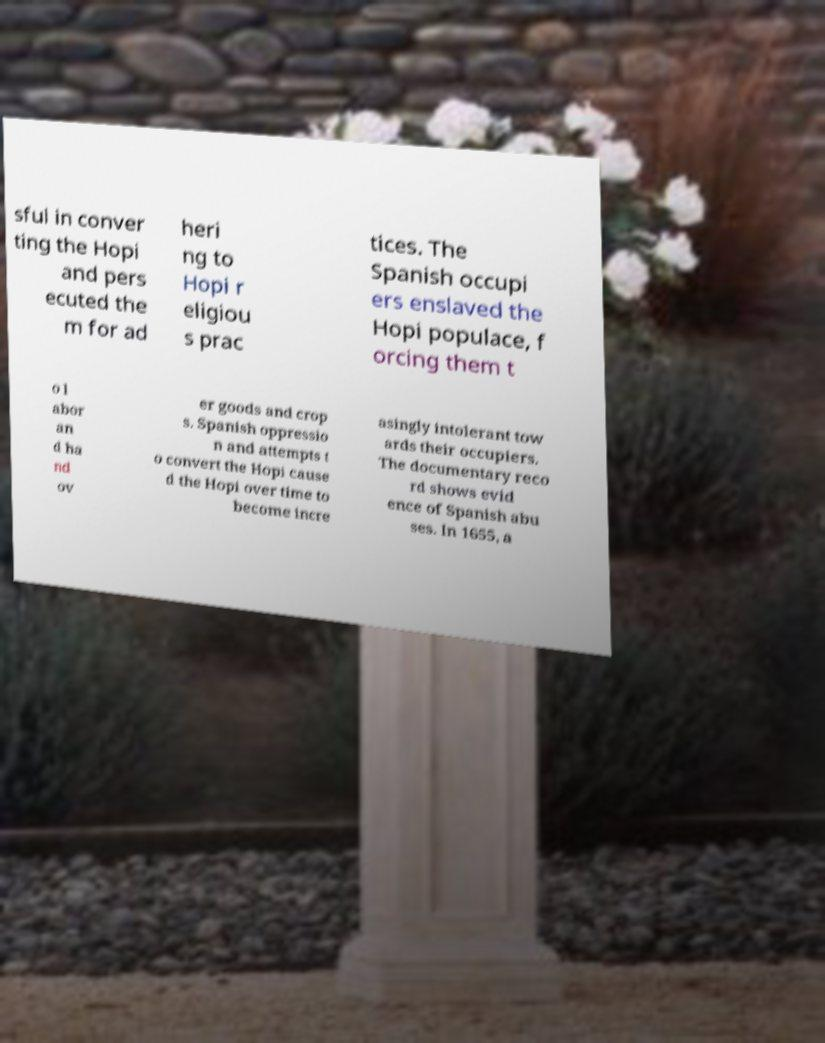For documentation purposes, I need the text within this image transcribed. Could you provide that? sful in conver ting the Hopi and pers ecuted the m for ad heri ng to Hopi r eligiou s prac tices. The Spanish occupi ers enslaved the Hopi populace, f orcing them t o l abor an d ha nd ov er goods and crop s. Spanish oppressio n and attempts t o convert the Hopi cause d the Hopi over time to become incre asingly intolerant tow ards their occupiers. The documentary reco rd shows evid ence of Spanish abu ses. In 1655, a 